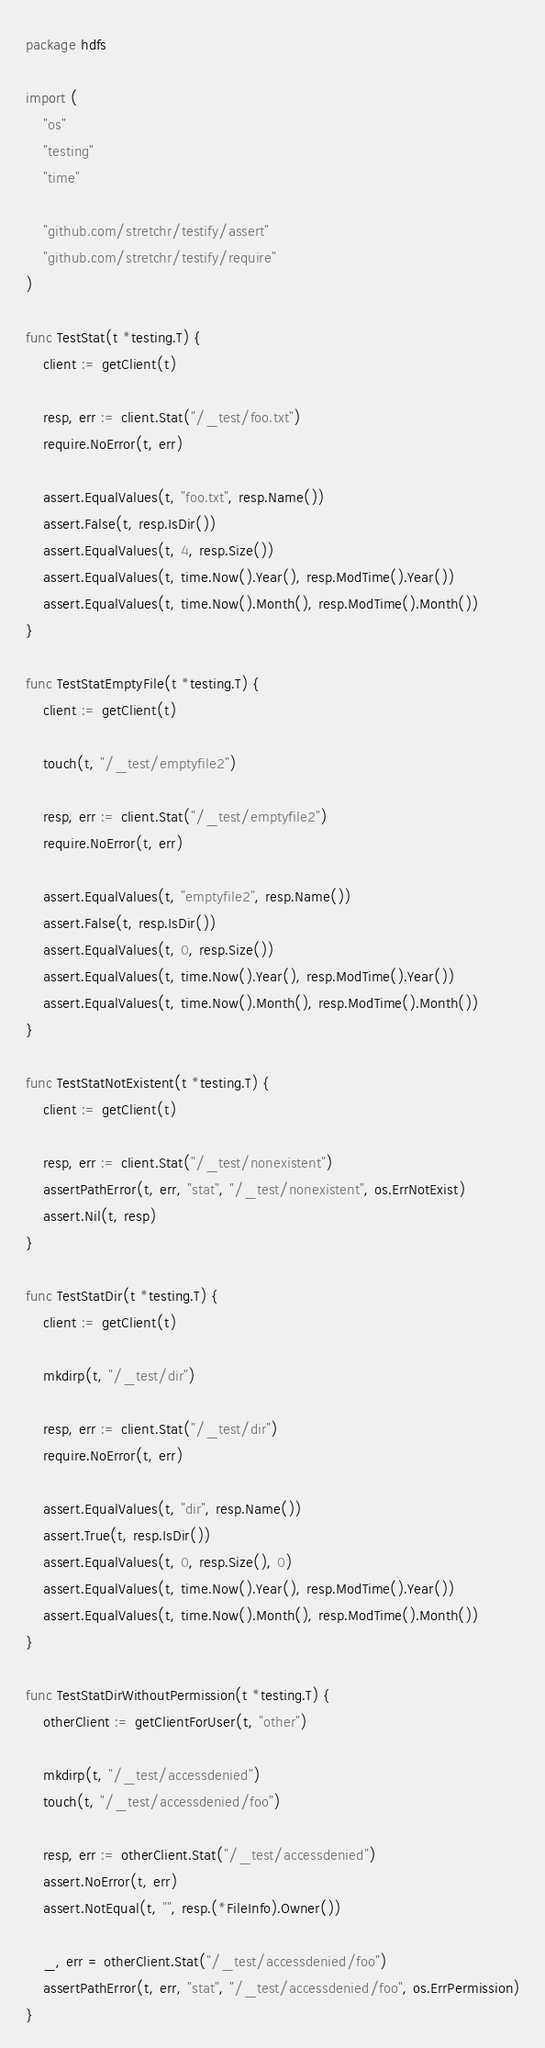<code> <loc_0><loc_0><loc_500><loc_500><_Go_>package hdfs

import (
	"os"
	"testing"
	"time"

	"github.com/stretchr/testify/assert"
	"github.com/stretchr/testify/require"
)

func TestStat(t *testing.T) {
	client := getClient(t)

	resp, err := client.Stat("/_test/foo.txt")
	require.NoError(t, err)

	assert.EqualValues(t, "foo.txt", resp.Name())
	assert.False(t, resp.IsDir())
	assert.EqualValues(t, 4, resp.Size())
	assert.EqualValues(t, time.Now().Year(), resp.ModTime().Year())
	assert.EqualValues(t, time.Now().Month(), resp.ModTime().Month())
}

func TestStatEmptyFile(t *testing.T) {
	client := getClient(t)

	touch(t, "/_test/emptyfile2")

	resp, err := client.Stat("/_test/emptyfile2")
	require.NoError(t, err)

	assert.EqualValues(t, "emptyfile2", resp.Name())
	assert.False(t, resp.IsDir())
	assert.EqualValues(t, 0, resp.Size())
	assert.EqualValues(t, time.Now().Year(), resp.ModTime().Year())
	assert.EqualValues(t, time.Now().Month(), resp.ModTime().Month())
}

func TestStatNotExistent(t *testing.T) {
	client := getClient(t)

	resp, err := client.Stat("/_test/nonexistent")
	assertPathError(t, err, "stat", "/_test/nonexistent", os.ErrNotExist)
	assert.Nil(t, resp)
}

func TestStatDir(t *testing.T) {
	client := getClient(t)

	mkdirp(t, "/_test/dir")

	resp, err := client.Stat("/_test/dir")
	require.NoError(t, err)

	assert.EqualValues(t, "dir", resp.Name())
	assert.True(t, resp.IsDir())
	assert.EqualValues(t, 0, resp.Size(), 0)
	assert.EqualValues(t, time.Now().Year(), resp.ModTime().Year())
	assert.EqualValues(t, time.Now().Month(), resp.ModTime().Month())
}

func TestStatDirWithoutPermission(t *testing.T) {
	otherClient := getClientForUser(t, "other")

	mkdirp(t, "/_test/accessdenied")
	touch(t, "/_test/accessdenied/foo")

	resp, err := otherClient.Stat("/_test/accessdenied")
	assert.NoError(t, err)
	assert.NotEqual(t, "", resp.(*FileInfo).Owner())

	_, err = otherClient.Stat("/_test/accessdenied/foo")
	assertPathError(t, err, "stat", "/_test/accessdenied/foo", os.ErrPermission)
}
</code> 